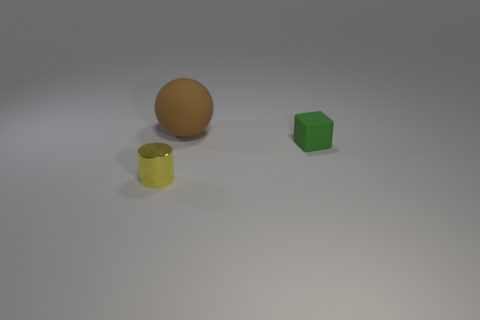Does the picture suggest anything about the lighting or atmosphere of the scene? The image showcases a rather soft and diffused lighting scenario, casting gentle shadows behind the objects that give a sense of calm and simplicity. The shadows are not very sharp, which suggests the light source is not very close. The background is a neutral grey, adding to the minimalistic atmosphere and making the colored objects stand out. 